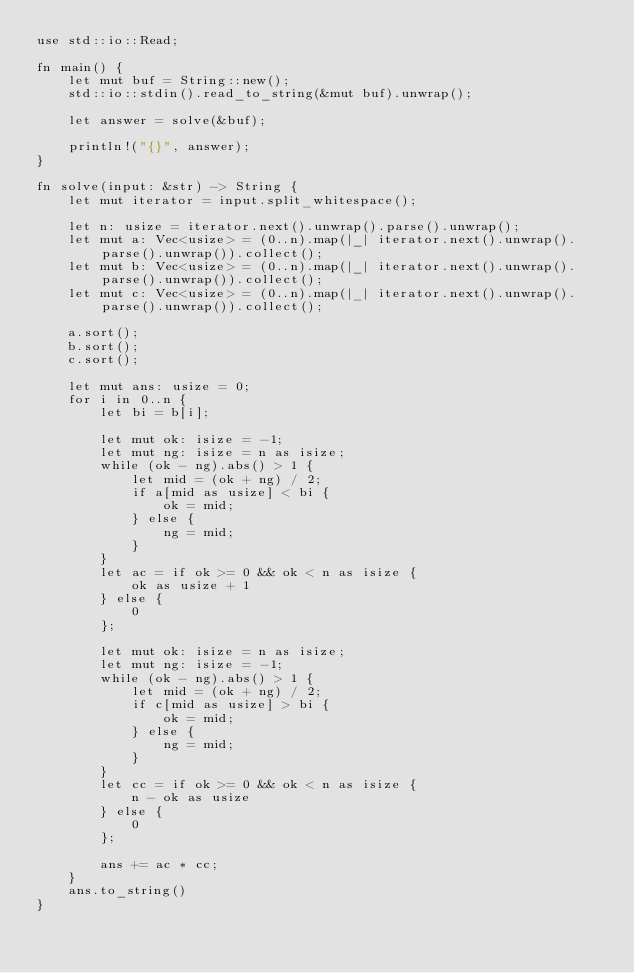<code> <loc_0><loc_0><loc_500><loc_500><_Rust_>use std::io::Read;

fn main() {
    let mut buf = String::new();
    std::io::stdin().read_to_string(&mut buf).unwrap();

    let answer = solve(&buf);

    println!("{}", answer);
}

fn solve(input: &str) -> String {
    let mut iterator = input.split_whitespace();

    let n: usize = iterator.next().unwrap().parse().unwrap();
    let mut a: Vec<usize> = (0..n).map(|_| iterator.next().unwrap().parse().unwrap()).collect();
    let mut b: Vec<usize> = (0..n).map(|_| iterator.next().unwrap().parse().unwrap()).collect();
    let mut c: Vec<usize> = (0..n).map(|_| iterator.next().unwrap().parse().unwrap()).collect();

    a.sort();
    b.sort();
    c.sort();

    let mut ans: usize = 0;
    for i in 0..n {
        let bi = b[i];

        let mut ok: isize = -1;
        let mut ng: isize = n as isize;
        while (ok - ng).abs() > 1 {
            let mid = (ok + ng) / 2;
            if a[mid as usize] < bi {
                ok = mid;
            } else {
                ng = mid;
            }
        }
        let ac = if ok >= 0 && ok < n as isize {
            ok as usize + 1
        } else {
            0
        };

        let mut ok: isize = n as isize;
        let mut ng: isize = -1;
        while (ok - ng).abs() > 1 {
            let mid = (ok + ng) / 2;
            if c[mid as usize] > bi {
                ok = mid;
            } else {
                ng = mid;
            }
        }
        let cc = if ok >= 0 && ok < n as isize {
            n - ok as usize
        } else {
            0
        };

        ans += ac * cc;
    }
    ans.to_string()
}
</code> 